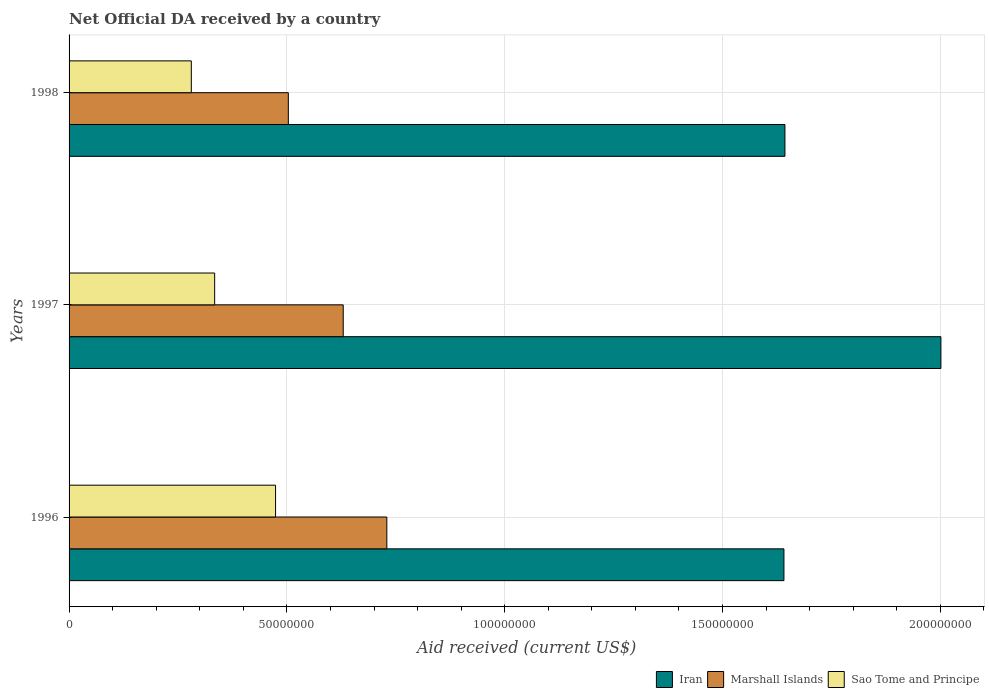How many different coloured bars are there?
Keep it short and to the point. 3. How many groups of bars are there?
Offer a terse response. 3. Are the number of bars per tick equal to the number of legend labels?
Give a very brief answer. Yes. How many bars are there on the 1st tick from the top?
Your answer should be compact. 3. What is the label of the 3rd group of bars from the top?
Ensure brevity in your answer.  1996. In how many cases, is the number of bars for a given year not equal to the number of legend labels?
Make the answer very short. 0. What is the net official development assistance aid received in Marshall Islands in 1997?
Make the answer very short. 6.29e+07. Across all years, what is the maximum net official development assistance aid received in Marshall Islands?
Give a very brief answer. 7.29e+07. Across all years, what is the minimum net official development assistance aid received in Iran?
Provide a short and direct response. 1.64e+08. In which year was the net official development assistance aid received in Iran minimum?
Ensure brevity in your answer.  1996. What is the total net official development assistance aid received in Iran in the graph?
Your response must be concise. 5.29e+08. What is the difference between the net official development assistance aid received in Iran in 1996 and that in 1997?
Your answer should be compact. -3.60e+07. What is the difference between the net official development assistance aid received in Marshall Islands in 1996 and the net official development assistance aid received in Sao Tome and Principe in 1997?
Provide a short and direct response. 3.95e+07. What is the average net official development assistance aid received in Marshall Islands per year?
Make the answer very short. 6.21e+07. In the year 1996, what is the difference between the net official development assistance aid received in Iran and net official development assistance aid received in Sao Tome and Principe?
Ensure brevity in your answer.  1.17e+08. What is the ratio of the net official development assistance aid received in Iran in 1996 to that in 1997?
Your answer should be very brief. 0.82. What is the difference between the highest and the second highest net official development assistance aid received in Iran?
Provide a short and direct response. 3.58e+07. What is the difference between the highest and the lowest net official development assistance aid received in Iran?
Offer a very short reply. 3.60e+07. Is the sum of the net official development assistance aid received in Marshall Islands in 1996 and 1997 greater than the maximum net official development assistance aid received in Iran across all years?
Give a very brief answer. No. What does the 2nd bar from the top in 1996 represents?
Keep it short and to the point. Marshall Islands. What does the 1st bar from the bottom in 1997 represents?
Your answer should be very brief. Iran. How many years are there in the graph?
Give a very brief answer. 3. Are the values on the major ticks of X-axis written in scientific E-notation?
Your response must be concise. No. Does the graph contain any zero values?
Your answer should be compact. No. Does the graph contain grids?
Your answer should be very brief. Yes. How are the legend labels stacked?
Keep it short and to the point. Horizontal. What is the title of the graph?
Ensure brevity in your answer.  Net Official DA received by a country. What is the label or title of the X-axis?
Your response must be concise. Aid received (current US$). What is the Aid received (current US$) of Iran in 1996?
Provide a succinct answer. 1.64e+08. What is the Aid received (current US$) in Marshall Islands in 1996?
Provide a short and direct response. 7.29e+07. What is the Aid received (current US$) of Sao Tome and Principe in 1996?
Offer a very short reply. 4.74e+07. What is the Aid received (current US$) in Iran in 1997?
Your answer should be very brief. 2.00e+08. What is the Aid received (current US$) of Marshall Islands in 1997?
Give a very brief answer. 6.29e+07. What is the Aid received (current US$) in Sao Tome and Principe in 1997?
Give a very brief answer. 3.34e+07. What is the Aid received (current US$) in Iran in 1998?
Ensure brevity in your answer.  1.64e+08. What is the Aid received (current US$) in Marshall Islands in 1998?
Provide a succinct answer. 5.03e+07. What is the Aid received (current US$) in Sao Tome and Principe in 1998?
Provide a succinct answer. 2.81e+07. Across all years, what is the maximum Aid received (current US$) in Iran?
Provide a succinct answer. 2.00e+08. Across all years, what is the maximum Aid received (current US$) in Marshall Islands?
Provide a short and direct response. 7.29e+07. Across all years, what is the maximum Aid received (current US$) of Sao Tome and Principe?
Give a very brief answer. 4.74e+07. Across all years, what is the minimum Aid received (current US$) in Iran?
Provide a succinct answer. 1.64e+08. Across all years, what is the minimum Aid received (current US$) in Marshall Islands?
Your response must be concise. 5.03e+07. Across all years, what is the minimum Aid received (current US$) of Sao Tome and Principe?
Give a very brief answer. 2.81e+07. What is the total Aid received (current US$) in Iran in the graph?
Give a very brief answer. 5.29e+08. What is the total Aid received (current US$) in Marshall Islands in the graph?
Keep it short and to the point. 1.86e+08. What is the total Aid received (current US$) in Sao Tome and Principe in the graph?
Keep it short and to the point. 1.09e+08. What is the difference between the Aid received (current US$) in Iran in 1996 and that in 1997?
Make the answer very short. -3.60e+07. What is the difference between the Aid received (current US$) of Marshall Islands in 1996 and that in 1997?
Provide a succinct answer. 1.00e+07. What is the difference between the Aid received (current US$) in Sao Tome and Principe in 1996 and that in 1997?
Offer a very short reply. 1.40e+07. What is the difference between the Aid received (current US$) in Iran in 1996 and that in 1998?
Your response must be concise. -2.30e+05. What is the difference between the Aid received (current US$) of Marshall Islands in 1996 and that in 1998?
Make the answer very short. 2.26e+07. What is the difference between the Aid received (current US$) of Sao Tome and Principe in 1996 and that in 1998?
Your answer should be very brief. 1.93e+07. What is the difference between the Aid received (current US$) in Iran in 1997 and that in 1998?
Your answer should be very brief. 3.58e+07. What is the difference between the Aid received (current US$) of Marshall Islands in 1997 and that in 1998?
Your answer should be very brief. 1.26e+07. What is the difference between the Aid received (current US$) of Sao Tome and Principe in 1997 and that in 1998?
Offer a very short reply. 5.36e+06. What is the difference between the Aid received (current US$) of Iran in 1996 and the Aid received (current US$) of Marshall Islands in 1997?
Provide a succinct answer. 1.01e+08. What is the difference between the Aid received (current US$) of Iran in 1996 and the Aid received (current US$) of Sao Tome and Principe in 1997?
Give a very brief answer. 1.31e+08. What is the difference between the Aid received (current US$) in Marshall Islands in 1996 and the Aid received (current US$) in Sao Tome and Principe in 1997?
Give a very brief answer. 3.95e+07. What is the difference between the Aid received (current US$) in Iran in 1996 and the Aid received (current US$) in Marshall Islands in 1998?
Make the answer very short. 1.14e+08. What is the difference between the Aid received (current US$) of Iran in 1996 and the Aid received (current US$) of Sao Tome and Principe in 1998?
Offer a very short reply. 1.36e+08. What is the difference between the Aid received (current US$) of Marshall Islands in 1996 and the Aid received (current US$) of Sao Tome and Principe in 1998?
Keep it short and to the point. 4.49e+07. What is the difference between the Aid received (current US$) in Iran in 1997 and the Aid received (current US$) in Marshall Islands in 1998?
Your answer should be compact. 1.50e+08. What is the difference between the Aid received (current US$) in Iran in 1997 and the Aid received (current US$) in Sao Tome and Principe in 1998?
Provide a short and direct response. 1.72e+08. What is the difference between the Aid received (current US$) in Marshall Islands in 1997 and the Aid received (current US$) in Sao Tome and Principe in 1998?
Offer a very short reply. 3.49e+07. What is the average Aid received (current US$) of Iran per year?
Make the answer very short. 1.76e+08. What is the average Aid received (current US$) of Marshall Islands per year?
Provide a succinct answer. 6.21e+07. What is the average Aid received (current US$) of Sao Tome and Principe per year?
Provide a short and direct response. 3.63e+07. In the year 1996, what is the difference between the Aid received (current US$) of Iran and Aid received (current US$) of Marshall Islands?
Offer a very short reply. 9.12e+07. In the year 1996, what is the difference between the Aid received (current US$) of Iran and Aid received (current US$) of Sao Tome and Principe?
Your response must be concise. 1.17e+08. In the year 1996, what is the difference between the Aid received (current US$) in Marshall Islands and Aid received (current US$) in Sao Tome and Principe?
Your answer should be compact. 2.55e+07. In the year 1997, what is the difference between the Aid received (current US$) in Iran and Aid received (current US$) in Marshall Islands?
Give a very brief answer. 1.37e+08. In the year 1997, what is the difference between the Aid received (current US$) in Iran and Aid received (current US$) in Sao Tome and Principe?
Provide a succinct answer. 1.67e+08. In the year 1997, what is the difference between the Aid received (current US$) in Marshall Islands and Aid received (current US$) in Sao Tome and Principe?
Make the answer very short. 2.95e+07. In the year 1998, what is the difference between the Aid received (current US$) in Iran and Aid received (current US$) in Marshall Islands?
Your answer should be very brief. 1.14e+08. In the year 1998, what is the difference between the Aid received (current US$) in Iran and Aid received (current US$) in Sao Tome and Principe?
Your answer should be very brief. 1.36e+08. In the year 1998, what is the difference between the Aid received (current US$) of Marshall Islands and Aid received (current US$) of Sao Tome and Principe?
Your answer should be compact. 2.23e+07. What is the ratio of the Aid received (current US$) of Iran in 1996 to that in 1997?
Give a very brief answer. 0.82. What is the ratio of the Aid received (current US$) of Marshall Islands in 1996 to that in 1997?
Make the answer very short. 1.16. What is the ratio of the Aid received (current US$) in Sao Tome and Principe in 1996 to that in 1997?
Make the answer very short. 1.42. What is the ratio of the Aid received (current US$) in Marshall Islands in 1996 to that in 1998?
Your answer should be very brief. 1.45. What is the ratio of the Aid received (current US$) of Sao Tome and Principe in 1996 to that in 1998?
Keep it short and to the point. 1.69. What is the ratio of the Aid received (current US$) in Iran in 1997 to that in 1998?
Offer a very short reply. 1.22. What is the ratio of the Aid received (current US$) in Marshall Islands in 1997 to that in 1998?
Your response must be concise. 1.25. What is the ratio of the Aid received (current US$) of Sao Tome and Principe in 1997 to that in 1998?
Give a very brief answer. 1.19. What is the difference between the highest and the second highest Aid received (current US$) of Iran?
Provide a short and direct response. 3.58e+07. What is the difference between the highest and the second highest Aid received (current US$) in Marshall Islands?
Offer a very short reply. 1.00e+07. What is the difference between the highest and the second highest Aid received (current US$) of Sao Tome and Principe?
Make the answer very short. 1.40e+07. What is the difference between the highest and the lowest Aid received (current US$) of Iran?
Provide a succinct answer. 3.60e+07. What is the difference between the highest and the lowest Aid received (current US$) in Marshall Islands?
Give a very brief answer. 2.26e+07. What is the difference between the highest and the lowest Aid received (current US$) in Sao Tome and Principe?
Give a very brief answer. 1.93e+07. 